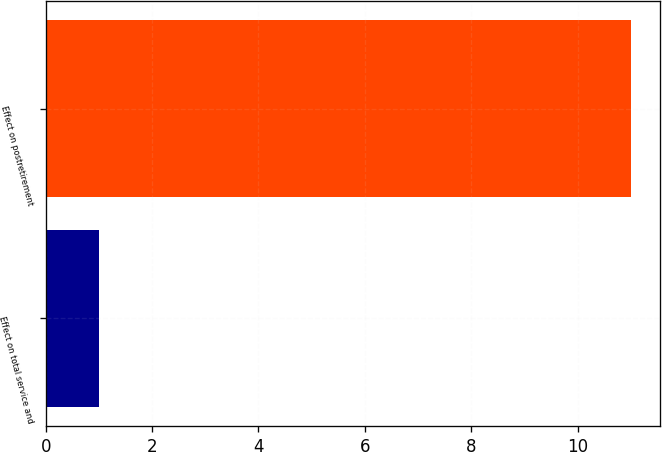Convert chart to OTSL. <chart><loc_0><loc_0><loc_500><loc_500><bar_chart><fcel>Effect on total service and<fcel>Effect on postretirement<nl><fcel>1<fcel>11<nl></chart> 